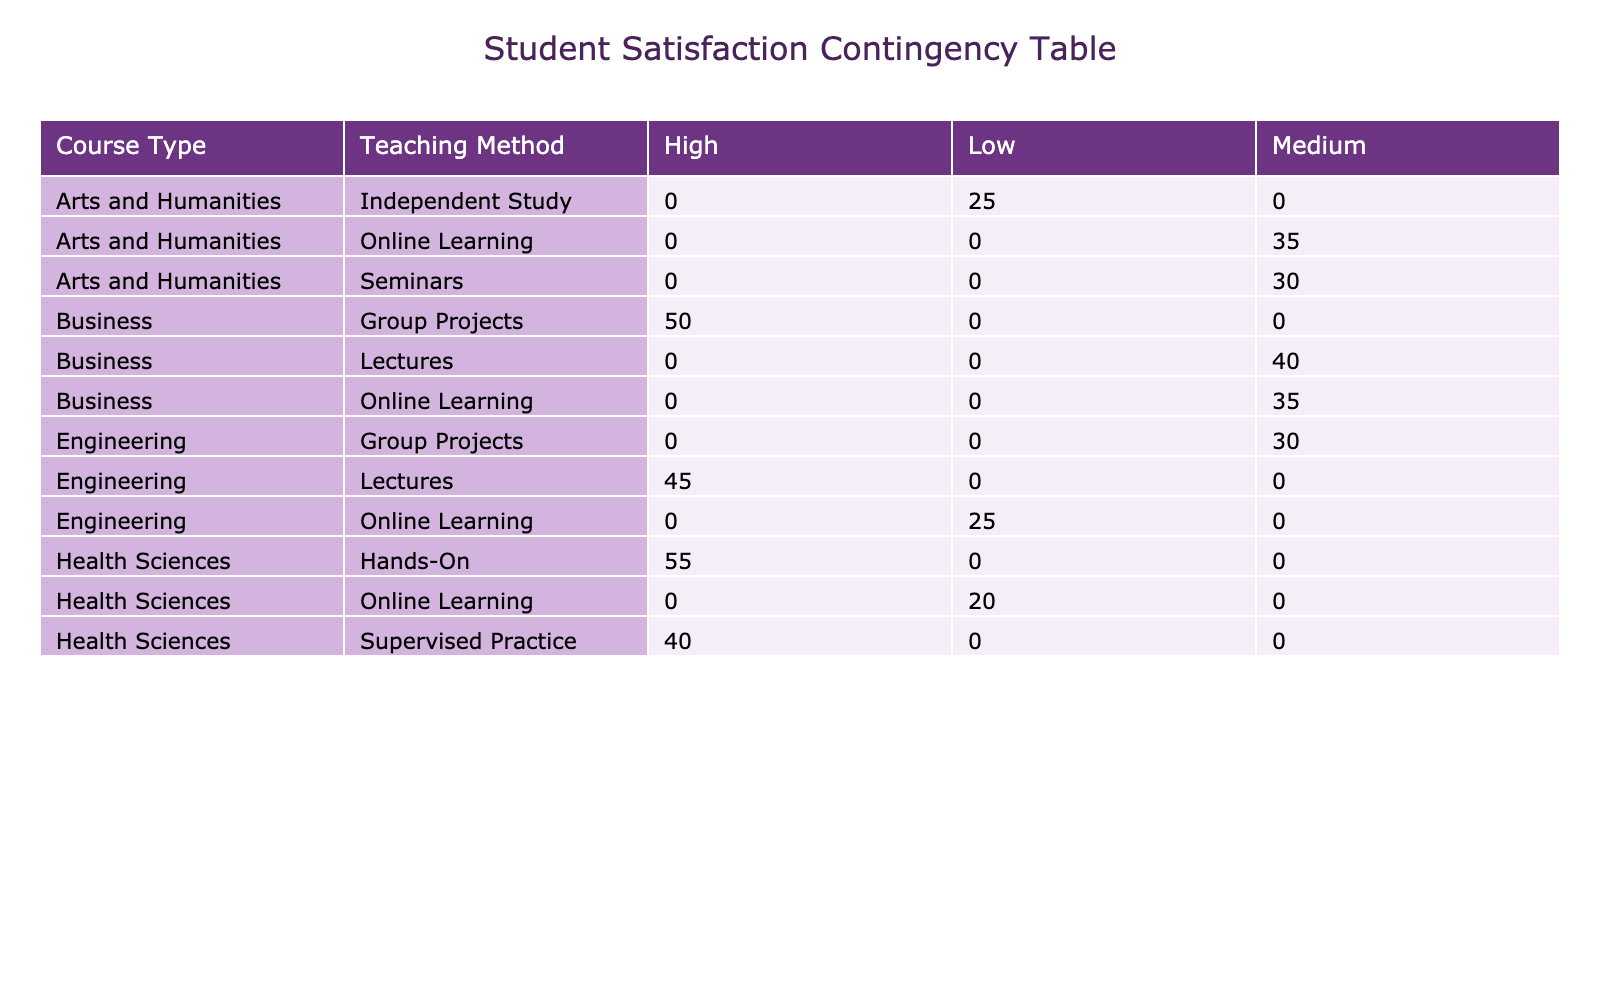What is the satisfaction level of students learning Engineering through Lectures? The table clearly indicates that for Engineering students learning through Lectures, the satisfaction level is categorized as High, according to the data.
Answer: High How many students reported a Medium satisfaction level for Business courses? By looking at the Business row, we can see there are two instances where the satisfaction level is Medium: one for Lectures with 40 students and one for Online Learning with 35 students. Adding these gives us a total of 40 + 35 = 75 students.
Answer: 75 Does the Health Sciences course have any students with Low satisfaction? The table shows that under the Health Sciences course, there is one teaching method—Online Learning—where the satisfaction level is Low, represented by 20 students. Thus, the answer is yes.
Answer: Yes What is the total number of students across all courses who reported High satisfaction levels? To find the total, we need to sum the Number of Students for all course types that have High satisfaction levels: Engineering (45), Business (50), and Health Sciences (55). Summing these gives 45 + 50 + 55 = 150.
Answer: 150 Which course type has the highest number of students reporting Low satisfaction levels, and what is the number? By evaluating the Low satisfaction levels across courses, we find that Engineering has 25 students and Health Sciences has 20. Thus, Engineering has the highest number at 25.
Answer: Engineering, 25 How many students reported a High satisfaction level for Group Projects in total? There is only one course type, Business, that reports a High satisfaction level for Group Projects with 50 students. No calculations are needed since there’s just one entry, leading us directly to the answer.
Answer: 50 Is the total number of students in Online Learning classrooms greater for Arts and Humanities than for Engineering? For Arts and Humanities, the number of students in Online Learning is 35, and for Engineering, it is 25. Comparing these two values shows that 35 > 25; therefore, the statement is true.
Answer: Yes What is the average number of students reporting Medium satisfaction levels across all courses? We have three instances of Medium satisfaction: Business-Lectures (40), Engineering-Group Projects (30), and Arts and Humanities-Online Learning (35). Adding these gives us a total of 40 + 30 + 35 = 105. There are three entries corresponding to these levels, so the average is 105 / 3 = 35.
Answer: 35 Which teaching method in Health Sciences has the highest satisfaction level and how many students were involved? The highest satisfaction level in Health Sciences is High, and two methods reflect this: Hands-On (55 students) and Supervised Practice (40 students). The Hands-On method has the highest number of students involved at 55.
Answer: Hands-On, 55 